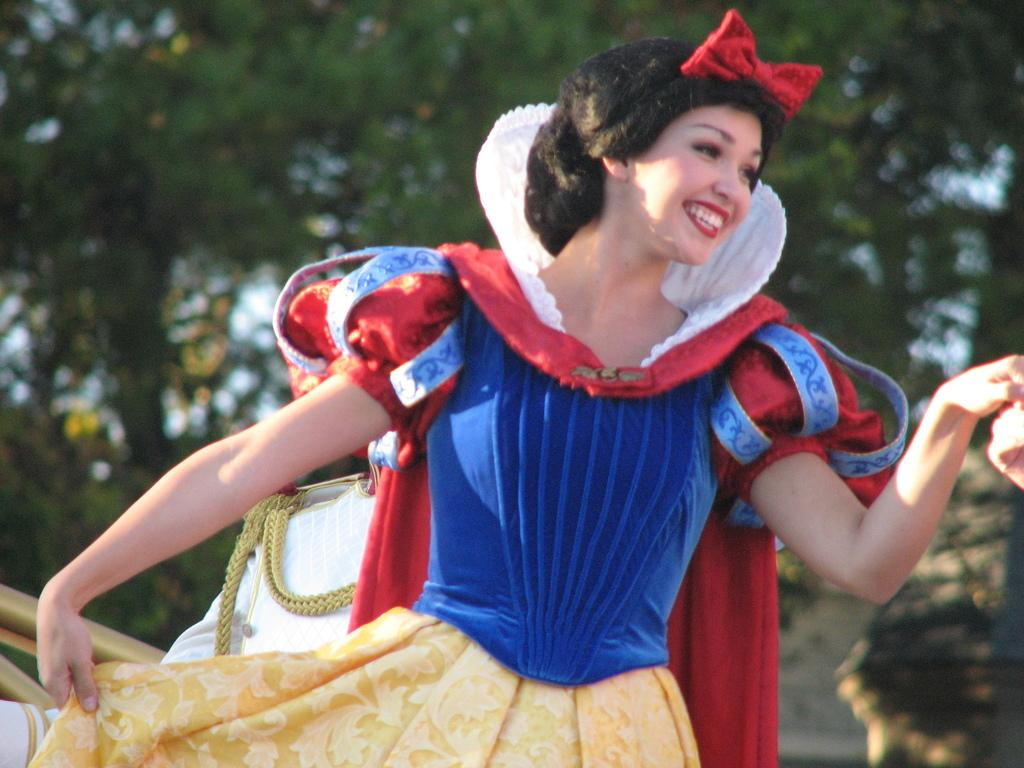What is the main subject of the image? There is a person in the image. Can you describe the person's appearance? The person is wearing clothes. What can be observed about the background of the image? The background of the image is blurred. What type of wheel can be seen supporting the person in the image? There is no wheel present in the image; it features a person standing or sitting. What form does the beam take in the image? There is no beam present in the image. 